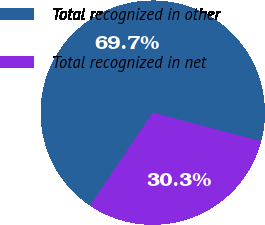Convert chart to OTSL. <chart><loc_0><loc_0><loc_500><loc_500><pie_chart><fcel>Total recognized in other<fcel>Total recognized in net<nl><fcel>69.68%<fcel>30.32%<nl></chart> 